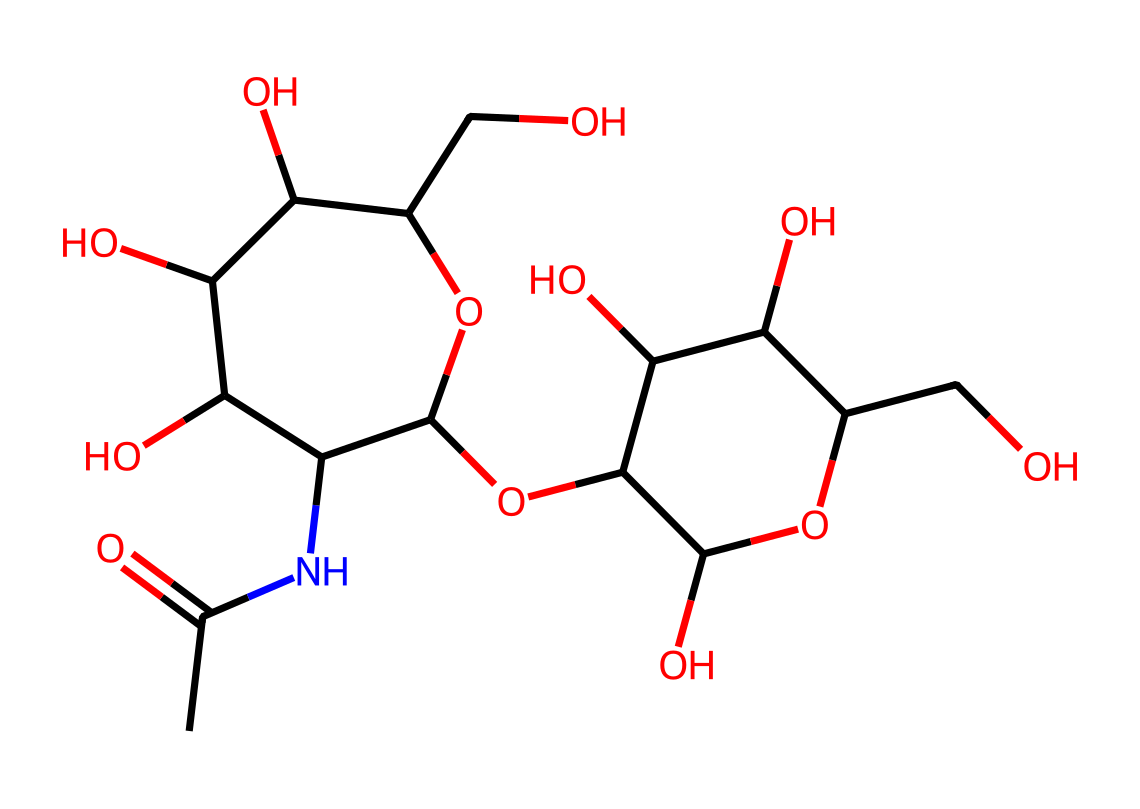What is the molecular formula of hyaluronic acid? To determine the molecular formula, we need to count the number of each type of atom in the SMILES representation. It contains Carbon (C), Hydrogen (H), Nitrogen (N), and Oxygen (O) atoms, which are grouped as follows: C = 14, H = 23, N = 1, O = 9. Combining these counts gives the molecular formula: C14H23NO9.
Answer: C14H23NO9 How many rings are present in the structure of hyaluronic acid? By analyzing the SMILES representation, we identify that the 'C1' and 'C2' indicates the presence of two rings in the structure. Each numbering denotes the start and end of a cycle, thus confirming the two cyclic structures.
Answer: 2 Does hyaluronic acid contain nitrogen? The presence of 'N' in the SMILES indicates that nitrogen is present in the molecular structure, confirming its presence in hyaluronic acid, specifically as part of the amide group (CC(=O)N).
Answer: Yes What type of functional group is present in hyaluronic acid? Looking at the onset of the chemical's structure, it shows an amide group represented as 'C(=O)N' as well as multiple hydroxyl groups (—OH) found throughout the structure, classifying it as having both amide and alcohol functional groups.
Answer: Amide and Alcohol Which part of the structure contributes to its hydrating properties? The multiple -OH (hydroxyl) groups observed in the structure are what render hyaluronic acid its hydrating properties due to their ability to form hydrogen bonds with water, enhancing moisture retention. These can be spotted by examining the repeated 'O' and attached 'H' seen multiple times within the structure.
Answer: Hydroxyl groups What is the significance of the "CC(=O)" segment in the SMILES notation? This segment indicates the presence of an acetyl group (C(=O)CH3) at the beginning of the structure. The carbonyl (C=O) bond paired with the adjacent methyl group (C) reveals that this portion of the molecule has implications for its charge and polarity, influencing its reactivity and interaction with other substances.
Answer: Acetyl group 